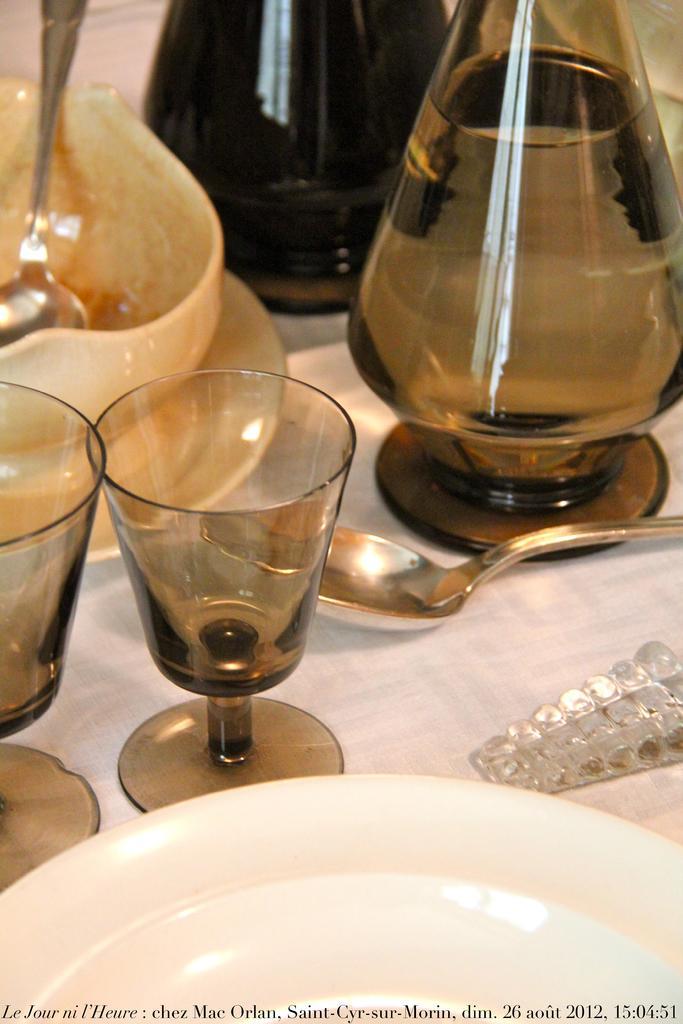In one or two sentences, can you explain what this image depicts? In this image, we can see plates, glasses, spoons, a bowl and some jars with water and an object are on the table. At the bottom, we can see some text. 